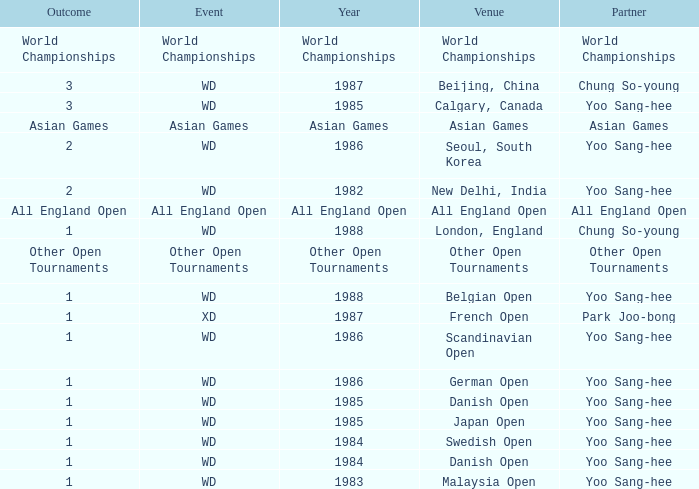What was the Outcome of the Danish Open in 1985? 1.0. 